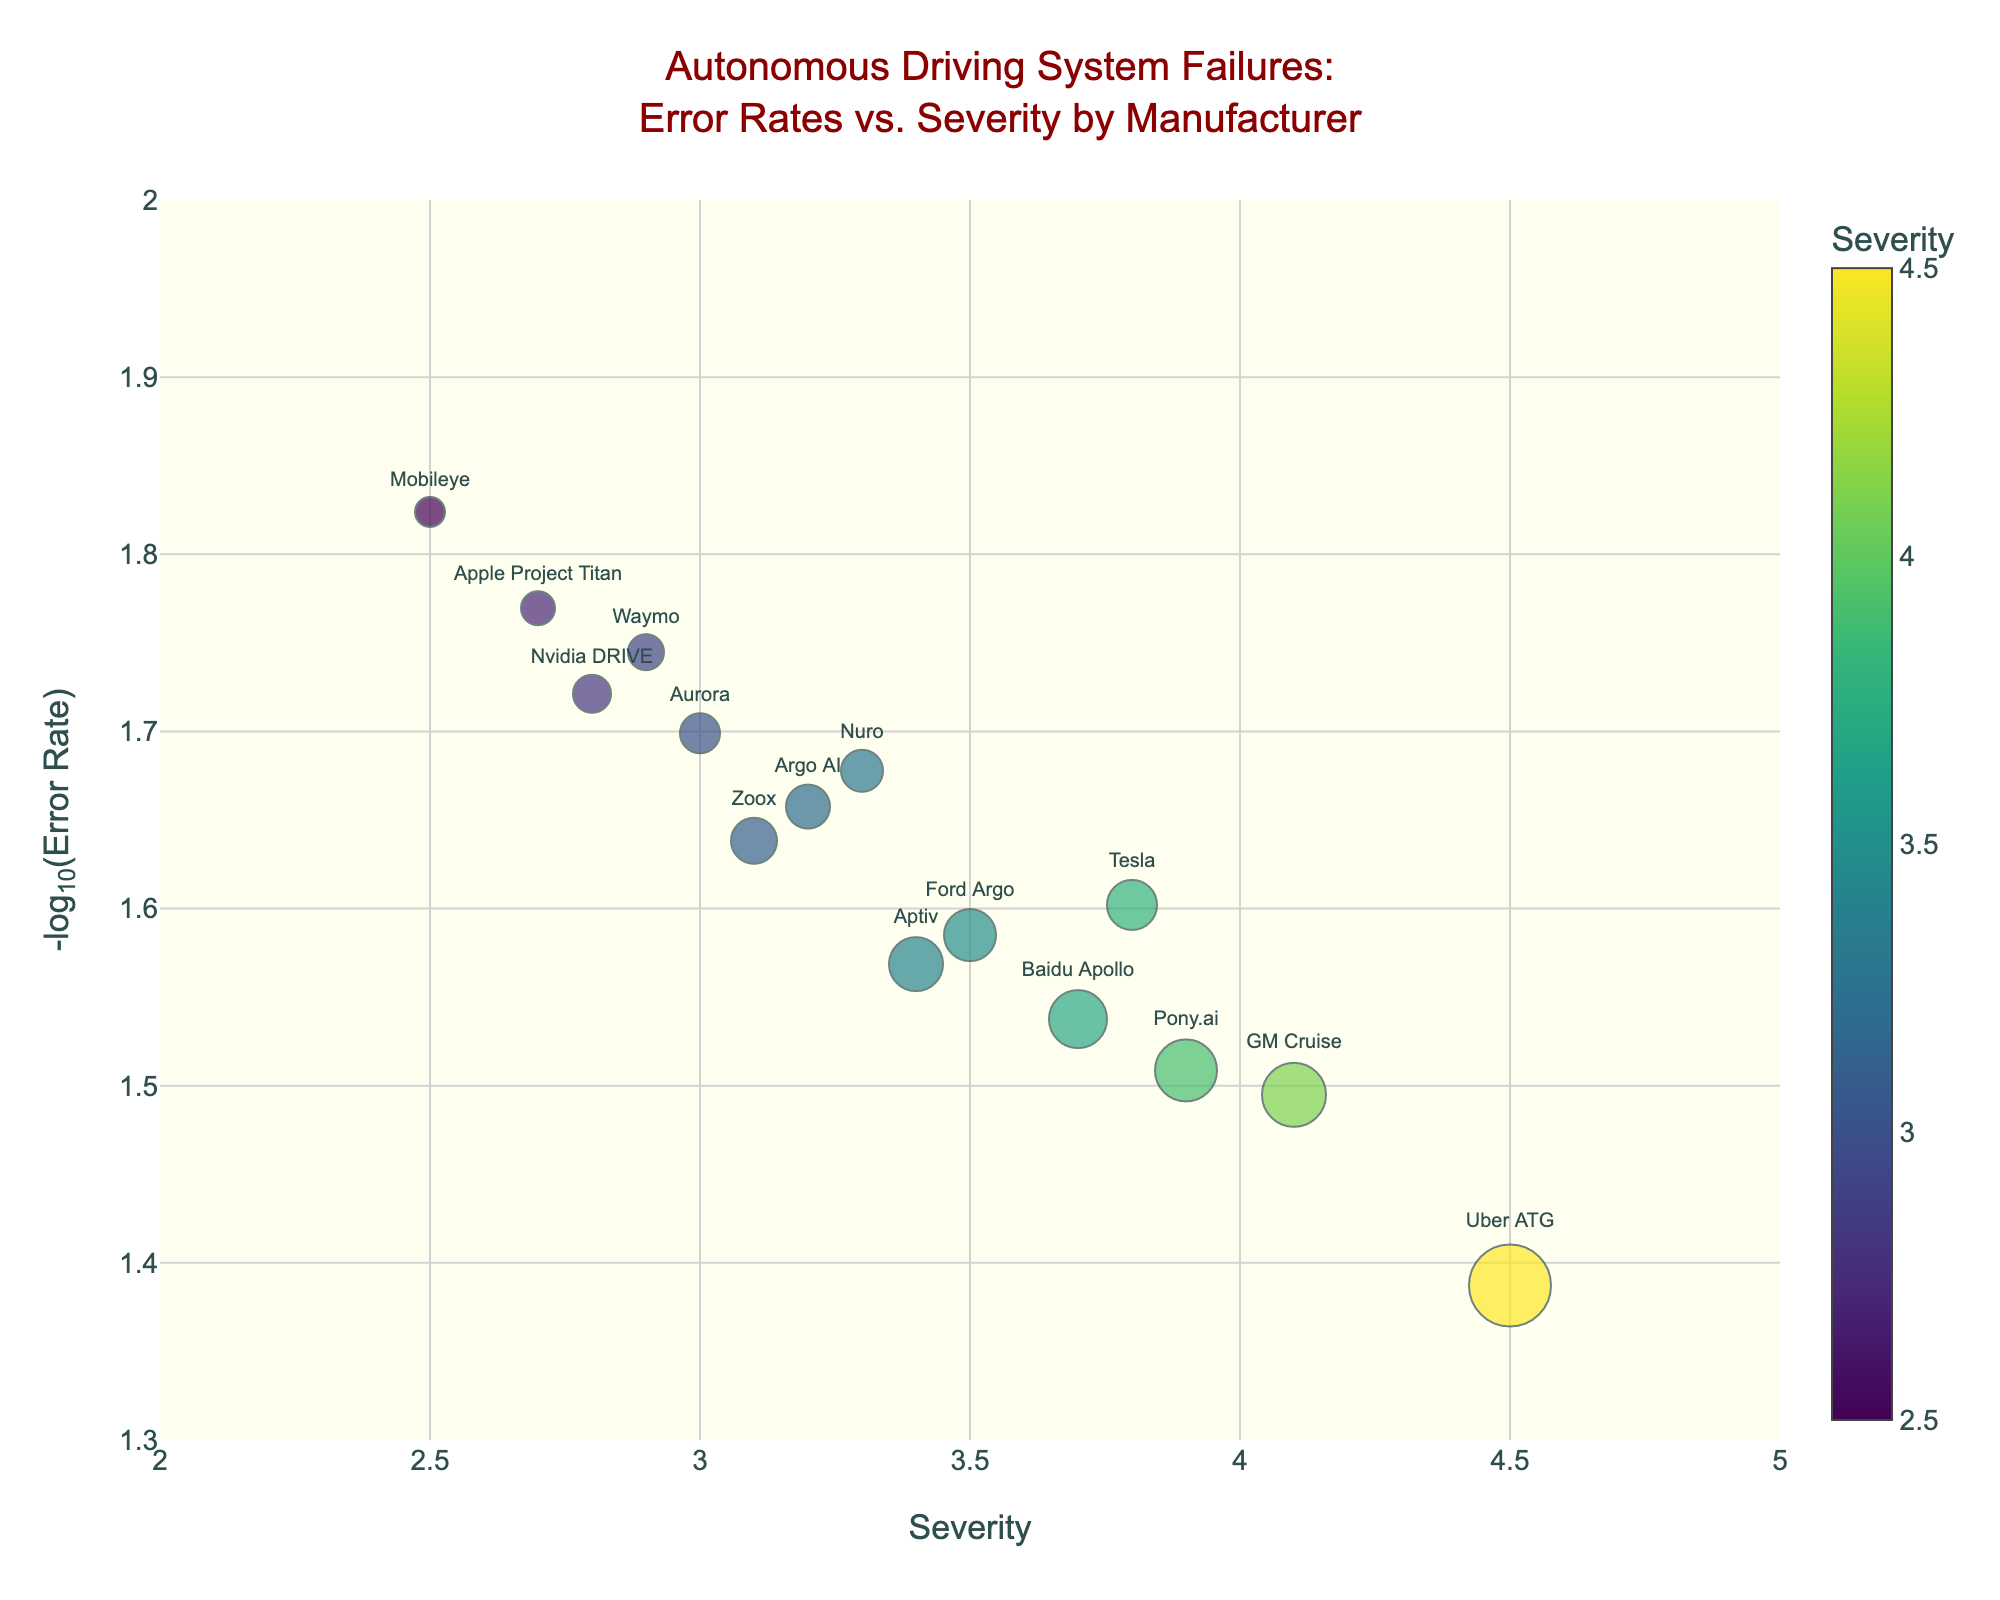What is the manufacturer with the highest severity in autonomous driving system failures? By examining the x-axis labeled "Severity," identify the data point that is farthest to the right. The manufacturer hovering around the highest value on the severity axis is Uber ATG with a severity of 4.5.
Answer: Uber ATG Which manufacturer has the lowest error rate in autonomous driving system failures? Look for the manufacturer with the highest value on the y-axis labeled "-log10(Error Rate)," since higher values of -log10(Error Rate) correspond to lower original error rates. The highest point on the y-axis is occupied by Mobileye.
Answer: Mobileye What is the error rate for Tesla? Locate Tesla in the plot by its label; then hover over the Tesla data point to view the error rate provided in the hovertemplate. The hovertemplate shows an error rate of 0.025.
Answer: 0.025 Among manufacturers with a severity greater than 4.0, which one has the lower error rate? Identify the data points with severity greater than 4.0 on the x-axis. Among them, compare their positions on the y-axis to find the highest value because a higher -log10(Error Rate) indicates a lower error rate. GM Cruise and Uber ATG have severities above 4.0, with GM Cruise having a higher value on the y-axis.
Answer: GM Cruise Which manufacturer has the largest marker size, indicating the highest error rate? Examine the plot for the biggest circle, which represents the largest error rate (since marker size is proportional to the error rate). The largest circle corresponds to Uber ATG.
Answer: Uber ATG Comparing Tesla and Waymo, which one has a higher severity? Locate the data points for Tesla and Waymo on the x-axis labeled "Severity" and compare their positions. Tesla is slightly to the right of Waymo, indicating a higher severity.
Answer: Tesla Which two manufacturers have similar severity values but different error rates? Look for data points positioned closely together on the x-axis but at different heights on the y-axis. Tesla and Baidu Apollo have similar severities around 3.7 but different y-axis positions indicating different error rates.
Answer: Tesla and Baidu Apollo What range of values does the y-axis (-log10 Error Rate) cover? The y-axis labels provide the range. It starts slightly above 1.3 and goes up to just below 2.0.
Answer: 1.3 to 2.0 How does the severity of Ford Argo compare to that of Aptiv? Locate Ford Argo and Aptiv on the x-axis (Severity) and compare their positions. Ford Argo is slightly to the right of Aptiv, indicating a higher severity.
Answer: Ford Argo Which manufacturer appears to balance a relatively low error rate and moderate severity? Identify a data point moderately positioned on the x-axis (Severity) and relatively high on the y-axis (-log10 Error Rate), which would strike a balance. Apple Project Titan has a moderate severity of 2.7 and a relatively low error rate.
Answer: Apple Project Titan 